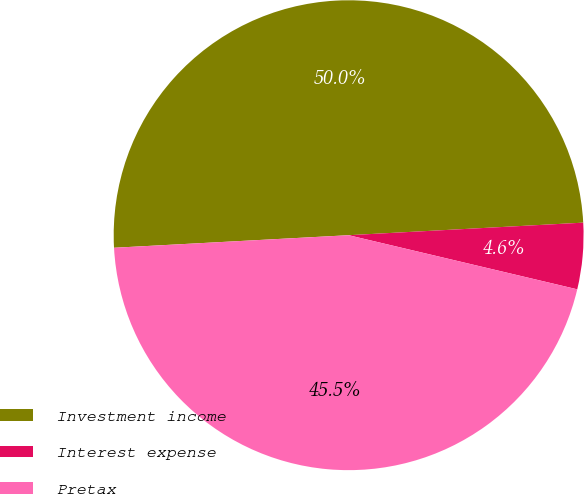Convert chart to OTSL. <chart><loc_0><loc_0><loc_500><loc_500><pie_chart><fcel>Investment income<fcel>Interest expense<fcel>Pretax<nl><fcel>50.0%<fcel>4.55%<fcel>45.45%<nl></chart> 